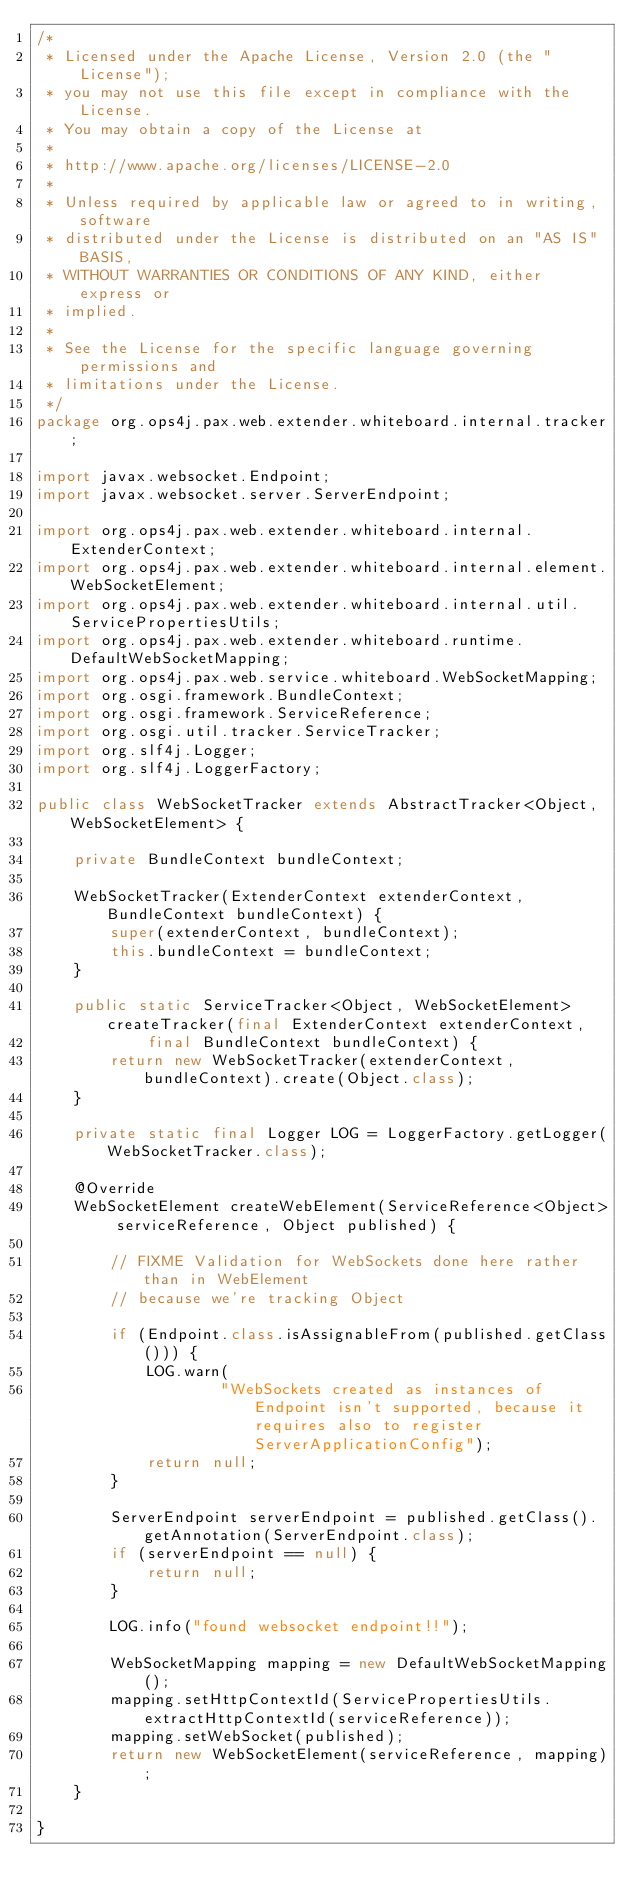Convert code to text. <code><loc_0><loc_0><loc_500><loc_500><_Java_>/*
 * Licensed under the Apache License, Version 2.0 (the "License");
 * you may not use this file except in compliance with the License.
 * You may obtain a copy of the License at
 *
 * http://www.apache.org/licenses/LICENSE-2.0
 *
 * Unless required by applicable law or agreed to in writing, software
 * distributed under the License is distributed on an "AS IS" BASIS,
 * WITHOUT WARRANTIES OR CONDITIONS OF ANY KIND, either express or
 * implied.
 *
 * See the License for the specific language governing permissions and
 * limitations under the License.
 */
package org.ops4j.pax.web.extender.whiteboard.internal.tracker;

import javax.websocket.Endpoint;
import javax.websocket.server.ServerEndpoint;

import org.ops4j.pax.web.extender.whiteboard.internal.ExtenderContext;
import org.ops4j.pax.web.extender.whiteboard.internal.element.WebSocketElement;
import org.ops4j.pax.web.extender.whiteboard.internal.util.ServicePropertiesUtils;
import org.ops4j.pax.web.extender.whiteboard.runtime.DefaultWebSocketMapping;
import org.ops4j.pax.web.service.whiteboard.WebSocketMapping;
import org.osgi.framework.BundleContext;
import org.osgi.framework.ServiceReference;
import org.osgi.util.tracker.ServiceTracker;
import org.slf4j.Logger;
import org.slf4j.LoggerFactory;

public class WebSocketTracker extends AbstractTracker<Object, WebSocketElement> {

	private BundleContext bundleContext;

	WebSocketTracker(ExtenderContext extenderContext, BundleContext bundleContext) {
		super(extenderContext, bundleContext);
		this.bundleContext = bundleContext;
	}

	public static ServiceTracker<Object, WebSocketElement> createTracker(final ExtenderContext extenderContext,
			final BundleContext bundleContext) {
		return new WebSocketTracker(extenderContext, bundleContext).create(Object.class);
	}

	private static final Logger LOG = LoggerFactory.getLogger(WebSocketTracker.class);

	@Override
	WebSocketElement createWebElement(ServiceReference<Object> serviceReference, Object published) {

		// FIXME Validation for WebSockets done here rather than in WebElement
		// because we're tracking Object

		if (Endpoint.class.isAssignableFrom(published.getClass())) {
			LOG.warn(
					"WebSockets created as instances of Endpoint isn't supported, because it requires also to register ServerApplicationConfig");
			return null;
		}

		ServerEndpoint serverEndpoint = published.getClass().getAnnotation(ServerEndpoint.class);
		if (serverEndpoint == null) {
			return null;
		}

		LOG.info("found websocket endpoint!!");

		WebSocketMapping mapping = new DefaultWebSocketMapping();
		mapping.setHttpContextId(ServicePropertiesUtils.extractHttpContextId(serviceReference));
		mapping.setWebSocket(published);
		return new WebSocketElement(serviceReference, mapping);
	}

}
</code> 